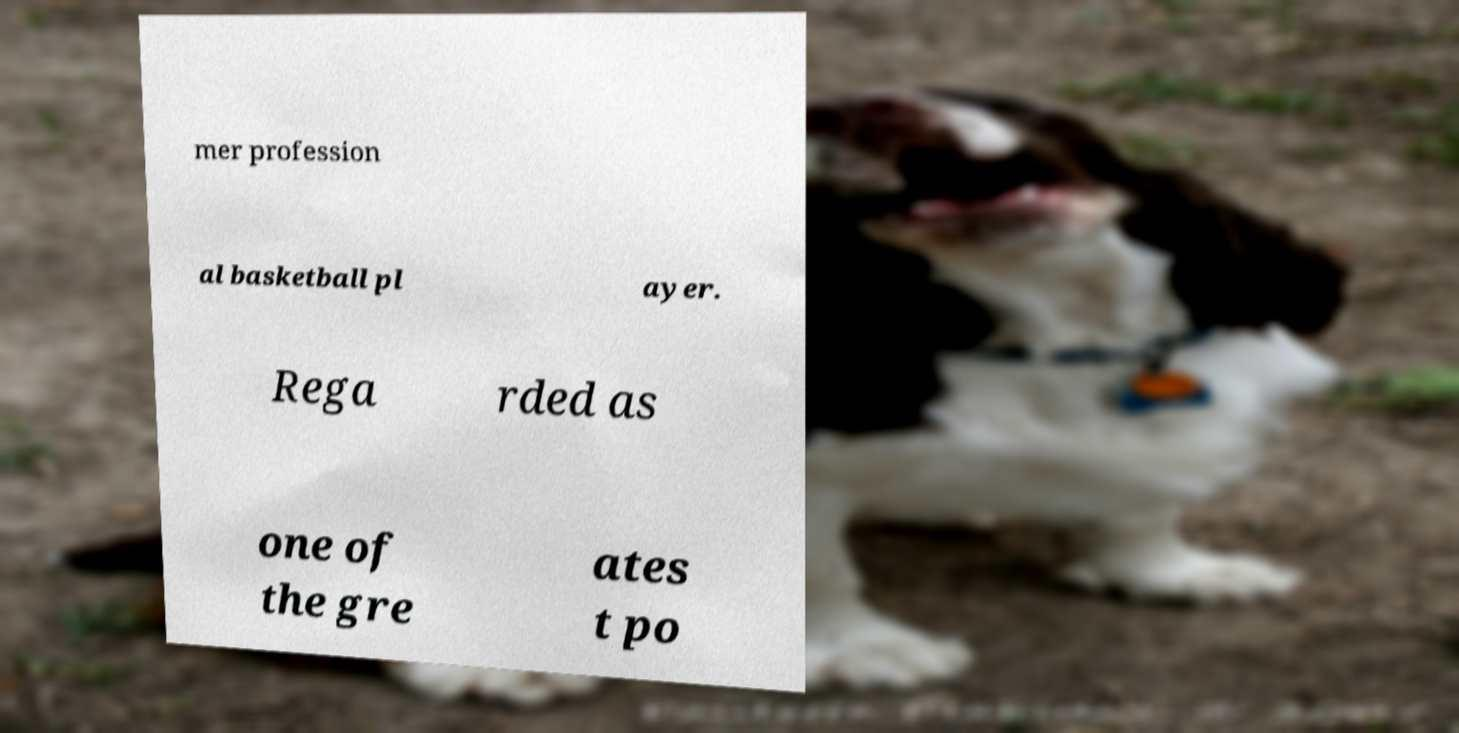Can you accurately transcribe the text from the provided image for me? mer profession al basketball pl ayer. Rega rded as one of the gre ates t po 